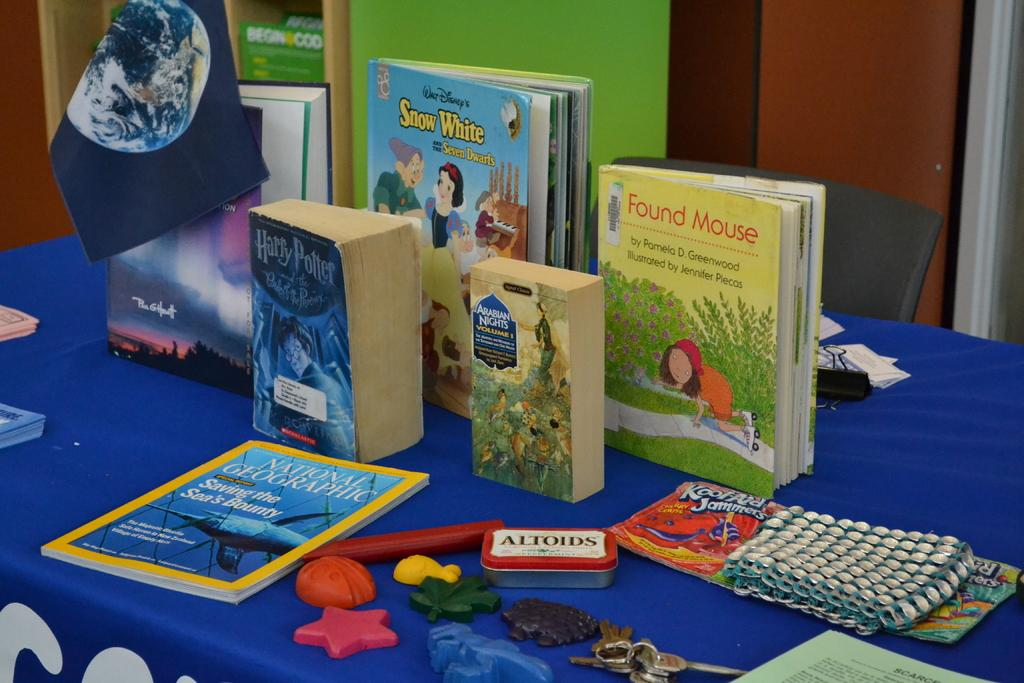<image>
Offer a succinct explanation of the picture presented. A national Geographic book is on the display along with some other children's books. 